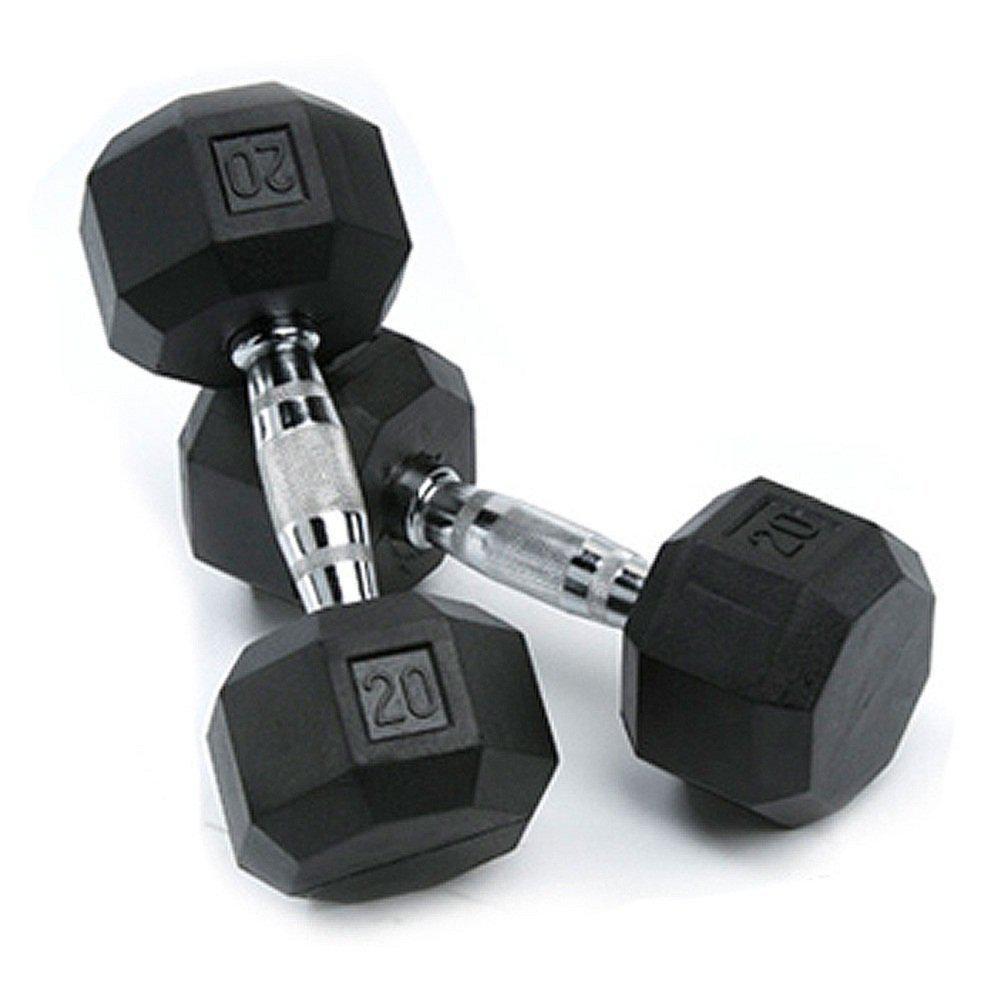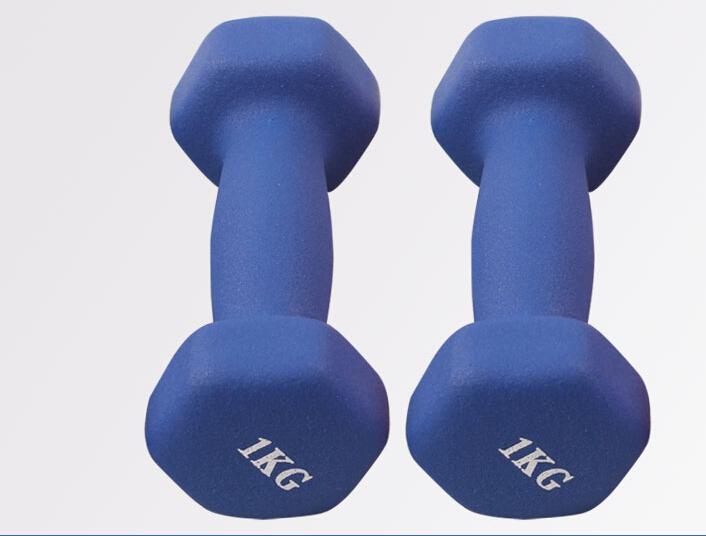The first image is the image on the left, the second image is the image on the right. For the images displayed, is the sentence "The right image contains two dumbbells with black ends and a chrome middle bar." factually correct? Answer yes or no. No. The first image is the image on the left, the second image is the image on the right. Examine the images to the left and right. Is the description "Two hand weights in each image are a matched set, dark colored weights with six sides that are attached to a metal bar." accurate? Answer yes or no. No. 